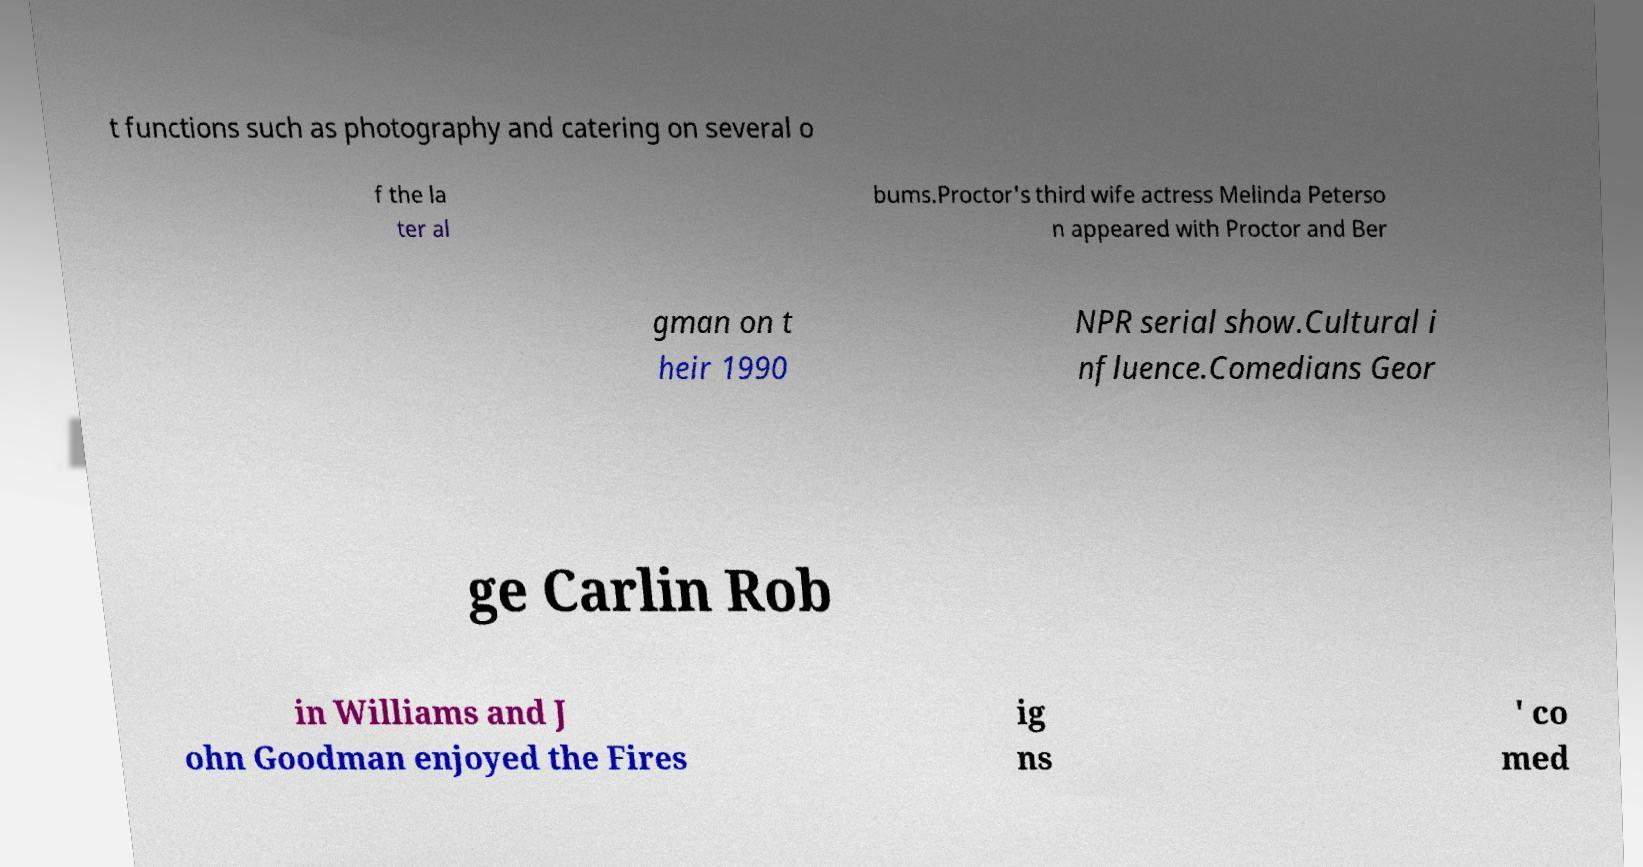For documentation purposes, I need the text within this image transcribed. Could you provide that? t functions such as photography and catering on several o f the la ter al bums.Proctor's third wife actress Melinda Peterso n appeared with Proctor and Ber gman on t heir 1990 NPR serial show.Cultural i nfluence.Comedians Geor ge Carlin Rob in Williams and J ohn Goodman enjoyed the Fires ig ns ' co med 